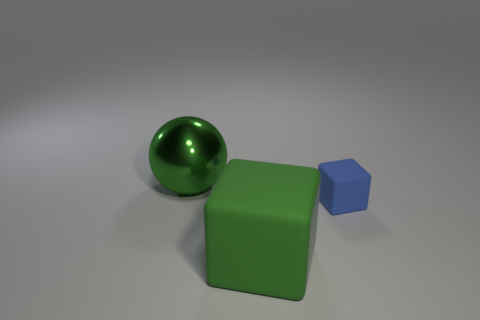Is there anything else of the same color as the tiny rubber object?
Provide a succinct answer. No. What is the size of the green thing that is on the left side of the rubber block in front of the blue rubber thing?
Keep it short and to the point. Large. What is the material of the thing that is the same size as the sphere?
Your answer should be compact. Rubber. What number of other objects are there of the same size as the green sphere?
Give a very brief answer. 1. How many spheres are either tiny blue rubber things or big metal things?
Your answer should be very brief. 1. Are there any other things that have the same material as the big sphere?
Your answer should be compact. No. There is a green thing in front of the large green object on the left side of the matte block that is to the left of the blue matte object; what is it made of?
Keep it short and to the point. Rubber. What is the material of the large ball that is the same color as the big block?
Keep it short and to the point. Metal. How many big green cubes are made of the same material as the small blue cube?
Your response must be concise. 1. There is a sphere that is on the left side of the green matte block; is its size the same as the blue rubber thing?
Provide a succinct answer. No. 